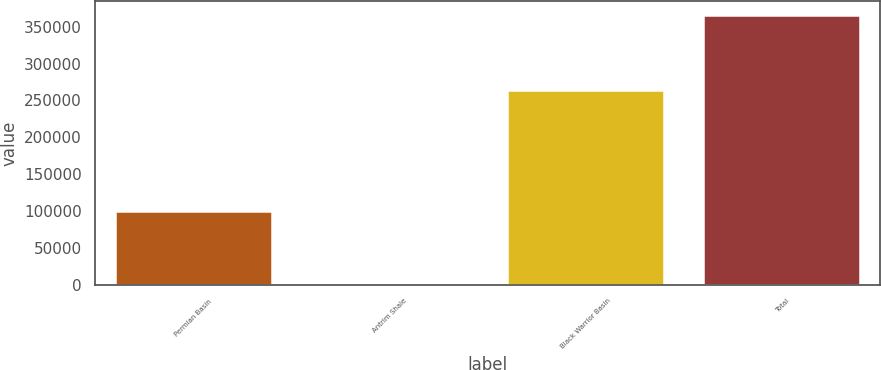Convert chart to OTSL. <chart><loc_0><loc_0><loc_500><loc_500><bar_chart><fcel>Permian Basin<fcel>Antrim Shale<fcel>Black Warrior Basin<fcel>Total<nl><fcel>99675<fcel>2300<fcel>264634<fcel>366609<nl></chart> 